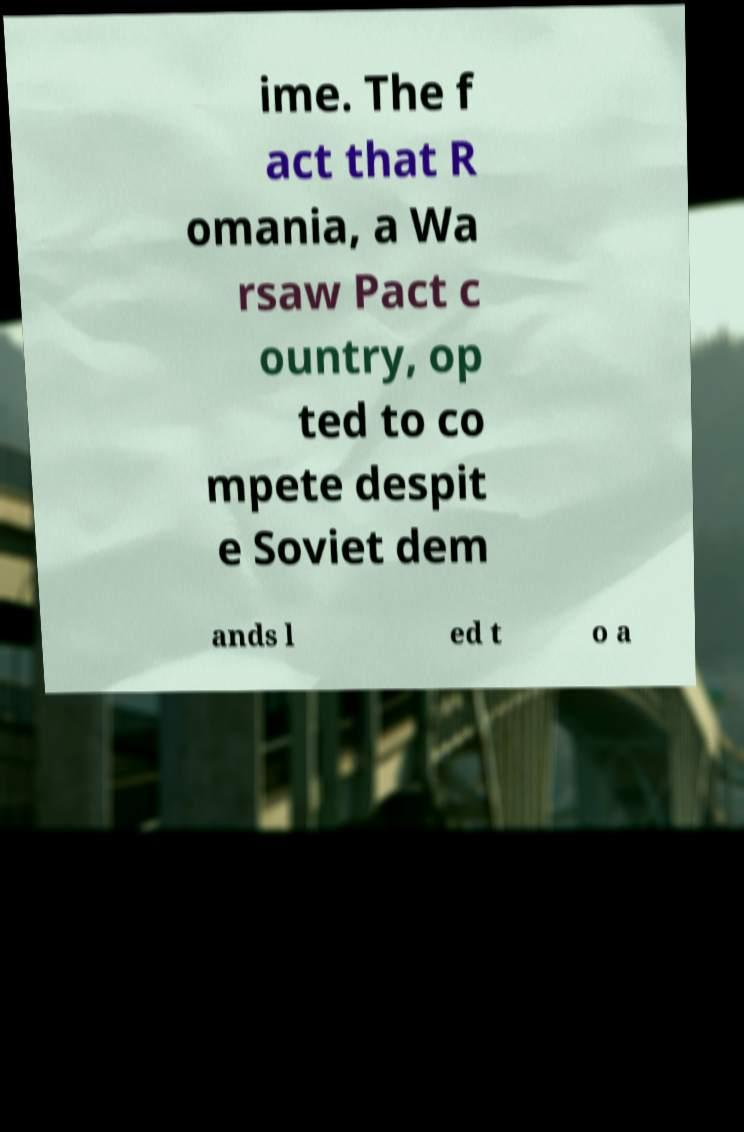What messages or text are displayed in this image? I need them in a readable, typed format. ime. The f act that R omania, a Wa rsaw Pact c ountry, op ted to co mpete despit e Soviet dem ands l ed t o a 